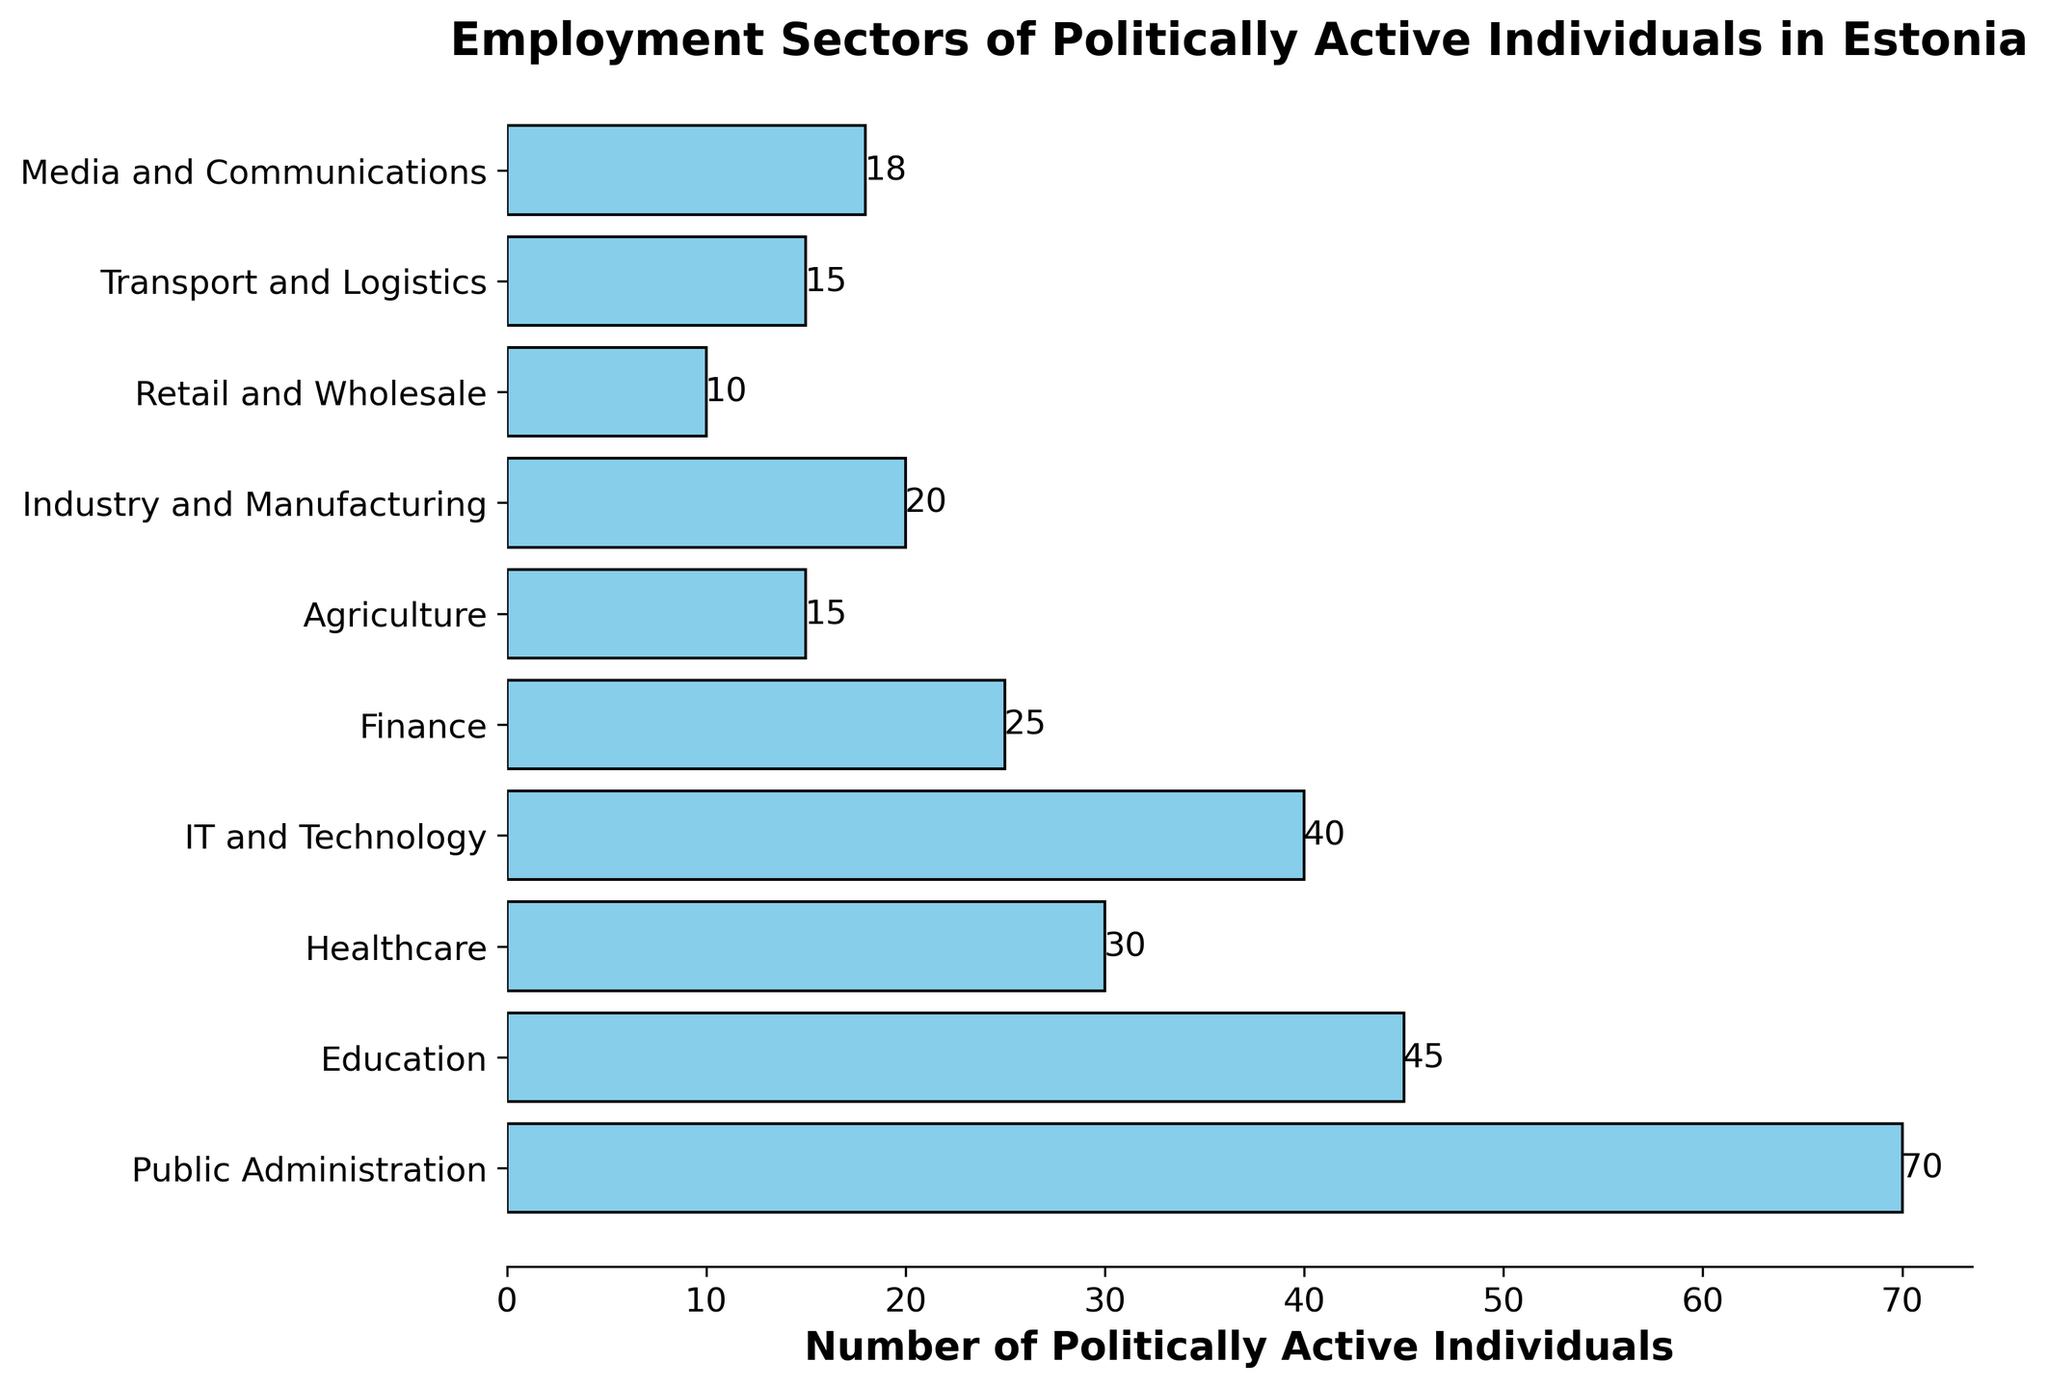Which sector has the highest number of politically active individuals? The bar for Public Administration is the longest, indicating it has the highest number of politically active individuals.
Answer: Public Administration Which sector has fewer politically active individuals, Healthcare or IT and Technology? The bar length for IT and Technology is slightly shorter than for Healthcare, meaning Healthcare has fewer.
Answer: Healthcare How many more politically active individuals are there in Education compared to Retail and Wholesale? Subtract the number of individuals in Retail and Wholesale (10) from those in Education (45). So, 45 - 10 = 35.
Answer: 35 What is the combined number of politically active individuals in Transport and Logistics, and Media and Communications? Add the number of individuals in Transport and Logistics (15) and Media and Communications (18). So, 15 + 18 = 33.
Answer: 33 Which sector has the second-highest number of politically active individuals? The second longest bar after Public Administration is Education.
Answer: Education Are there more politically active individuals in Industry and Manufacturing or Agriculture? The bar representing Industry and Manufacturing is slightly longer than that for Agriculture, indicating more in Industry and Manufacturing.
Answer: Industry and Manufacturing What is the total number of politically active individuals in IT and Technology, Finance, and Healthcare combined? Add the numbers from IT and Technology (40), Finance (25), and Healthcare (30). So, 40 + 25 + 30 = 95.
Answer: 95 Which sector has a number of politically active individuals closest to 20? Industry and Manufacturing has 20 politically active individuals, exactly matching the given number.
Answer: Industry and Manufacturing What's the difference in the number of politically active individuals between Public Administration and Finance? Subtract the number of individuals in Finance (25) from those in Public Administration (70). So, 70 - 25 = 45.
Answer: 45 Are the number of politically active individuals in Agriculture and Transport and Logistics equal? The bars for Agriculture and Transport and Logistics are of equal length, both representing 15 individuals.
Answer: Yes 